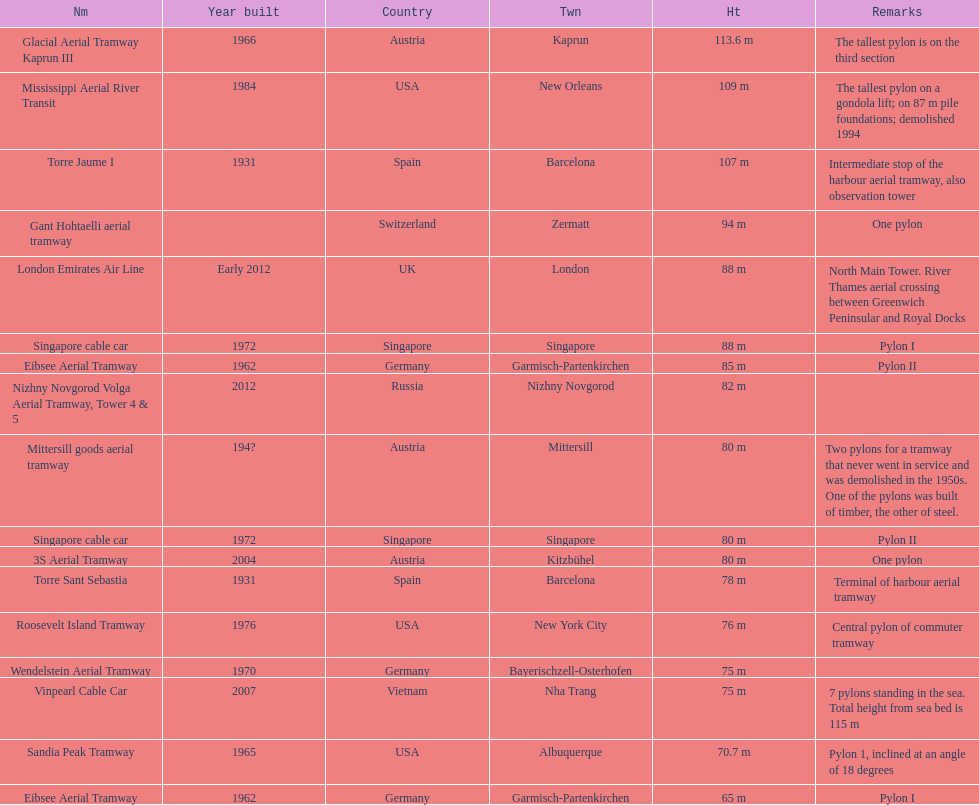How many pylons are at least 80 meters tall? 11. 